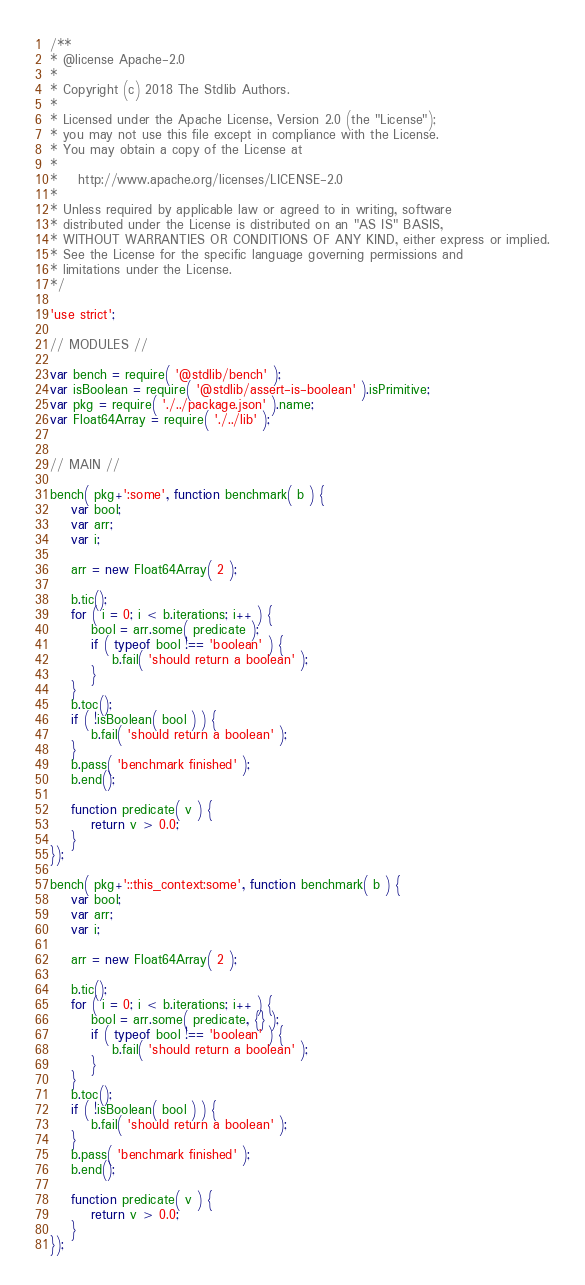<code> <loc_0><loc_0><loc_500><loc_500><_JavaScript_>/**
* @license Apache-2.0
*
* Copyright (c) 2018 The Stdlib Authors.
*
* Licensed under the Apache License, Version 2.0 (the "License");
* you may not use this file except in compliance with the License.
* You may obtain a copy of the License at
*
*    http://www.apache.org/licenses/LICENSE-2.0
*
* Unless required by applicable law or agreed to in writing, software
* distributed under the License is distributed on an "AS IS" BASIS,
* WITHOUT WARRANTIES OR CONDITIONS OF ANY KIND, either express or implied.
* See the License for the specific language governing permissions and
* limitations under the License.
*/

'use strict';

// MODULES //

var bench = require( '@stdlib/bench' );
var isBoolean = require( '@stdlib/assert-is-boolean' ).isPrimitive;
var pkg = require( './../package.json' ).name;
var Float64Array = require( './../lib' );


// MAIN //

bench( pkg+':some', function benchmark( b ) {
	var bool;
	var arr;
	var i;

	arr = new Float64Array( 2 );

	b.tic();
	for ( i = 0; i < b.iterations; i++ ) {
		bool = arr.some( predicate );
		if ( typeof bool !== 'boolean' ) {
			b.fail( 'should return a boolean' );
		}
	}
	b.toc();
	if ( !isBoolean( bool ) ) {
		b.fail( 'should return a boolean' );
	}
	b.pass( 'benchmark finished' );
	b.end();

	function predicate( v ) {
		return v > 0.0;
	}
});

bench( pkg+'::this_context:some', function benchmark( b ) {
	var bool;
	var arr;
	var i;

	arr = new Float64Array( 2 );

	b.tic();
	for ( i = 0; i < b.iterations; i++ ) {
		bool = arr.some( predicate, {} );
		if ( typeof bool !== 'boolean' ) {
			b.fail( 'should return a boolean' );
		}
	}
	b.toc();
	if ( !isBoolean( bool ) ) {
		b.fail( 'should return a boolean' );
	}
	b.pass( 'benchmark finished' );
	b.end();

	function predicate( v ) {
		return v > 0.0;
	}
});
</code> 